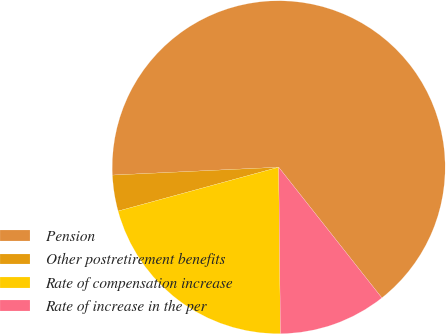Convert chart to OTSL. <chart><loc_0><loc_0><loc_500><loc_500><pie_chart><fcel>Pension<fcel>Other postretirement benefits<fcel>Rate of compensation increase<fcel>Rate of increase in the per<nl><fcel>65.12%<fcel>3.49%<fcel>20.93%<fcel>10.47%<nl></chart> 